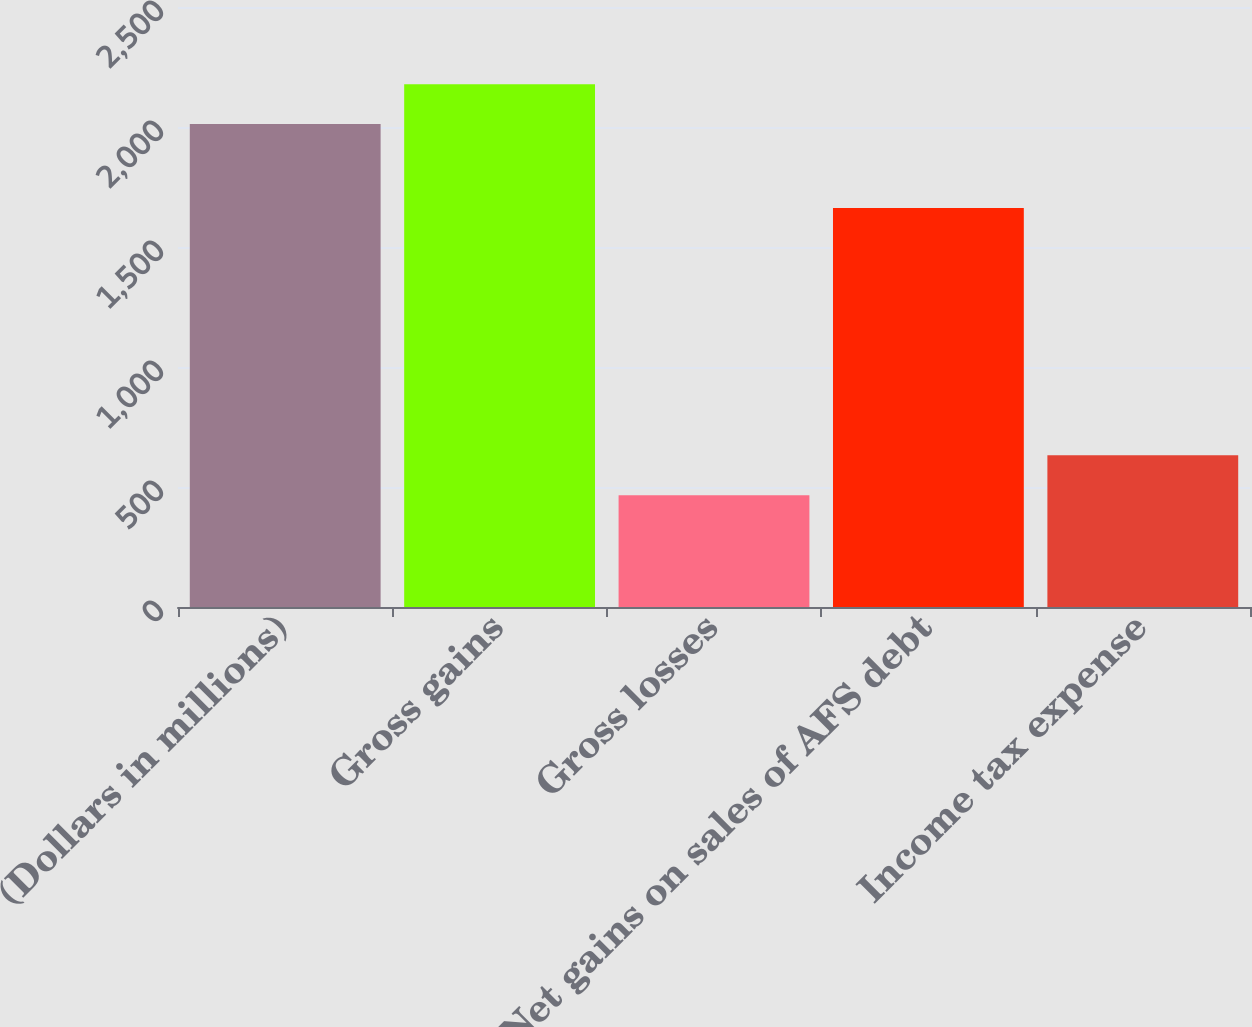Convert chart. <chart><loc_0><loc_0><loc_500><loc_500><bar_chart><fcel>(Dollars in millions)<fcel>Gross gains<fcel>Gross losses<fcel>Net gains on sales of AFS debt<fcel>Income tax expense<nl><fcel>2012<fcel>2178.2<fcel>466<fcel>1662<fcel>632.2<nl></chart> 